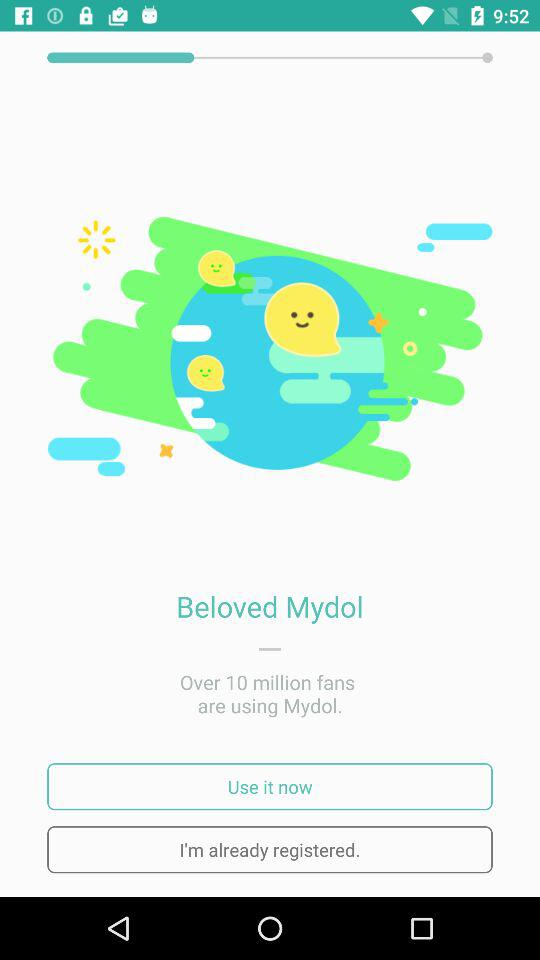How many fans are using "Mydol"? The number of fans using "Mydol" is over 10 million. 